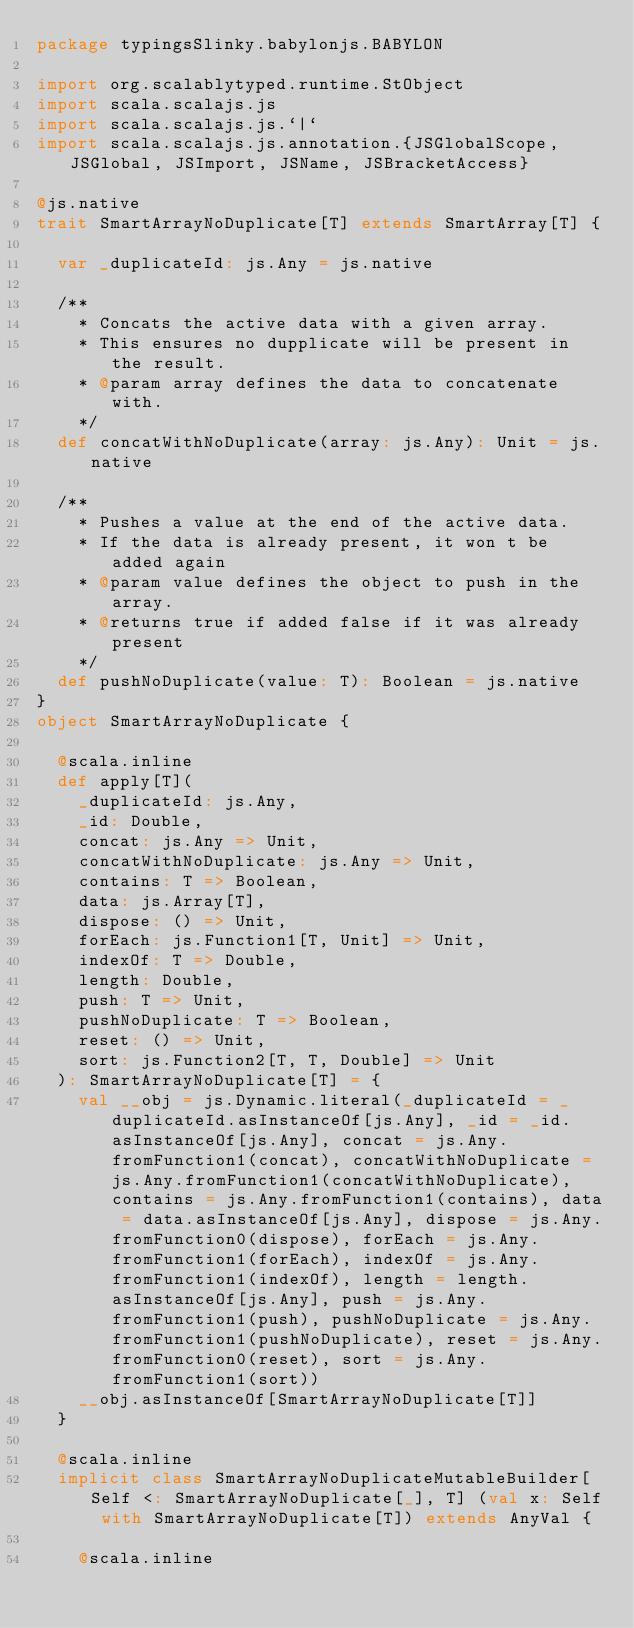Convert code to text. <code><loc_0><loc_0><loc_500><loc_500><_Scala_>package typingsSlinky.babylonjs.BABYLON

import org.scalablytyped.runtime.StObject
import scala.scalajs.js
import scala.scalajs.js.`|`
import scala.scalajs.js.annotation.{JSGlobalScope, JSGlobal, JSImport, JSName, JSBracketAccess}

@js.native
trait SmartArrayNoDuplicate[T] extends SmartArray[T] {
  
  var _duplicateId: js.Any = js.native
  
  /**
    * Concats the active data with a given array.
    * This ensures no dupplicate will be present in the result.
    * @param array defines the data to concatenate with.
    */
  def concatWithNoDuplicate(array: js.Any): Unit = js.native
  
  /**
    * Pushes a value at the end of the active data.
    * If the data is already present, it won t be added again
    * @param value defines the object to push in the array.
    * @returns true if added false if it was already present
    */
  def pushNoDuplicate(value: T): Boolean = js.native
}
object SmartArrayNoDuplicate {
  
  @scala.inline
  def apply[T](
    _duplicateId: js.Any,
    _id: Double,
    concat: js.Any => Unit,
    concatWithNoDuplicate: js.Any => Unit,
    contains: T => Boolean,
    data: js.Array[T],
    dispose: () => Unit,
    forEach: js.Function1[T, Unit] => Unit,
    indexOf: T => Double,
    length: Double,
    push: T => Unit,
    pushNoDuplicate: T => Boolean,
    reset: () => Unit,
    sort: js.Function2[T, T, Double] => Unit
  ): SmartArrayNoDuplicate[T] = {
    val __obj = js.Dynamic.literal(_duplicateId = _duplicateId.asInstanceOf[js.Any], _id = _id.asInstanceOf[js.Any], concat = js.Any.fromFunction1(concat), concatWithNoDuplicate = js.Any.fromFunction1(concatWithNoDuplicate), contains = js.Any.fromFunction1(contains), data = data.asInstanceOf[js.Any], dispose = js.Any.fromFunction0(dispose), forEach = js.Any.fromFunction1(forEach), indexOf = js.Any.fromFunction1(indexOf), length = length.asInstanceOf[js.Any], push = js.Any.fromFunction1(push), pushNoDuplicate = js.Any.fromFunction1(pushNoDuplicate), reset = js.Any.fromFunction0(reset), sort = js.Any.fromFunction1(sort))
    __obj.asInstanceOf[SmartArrayNoDuplicate[T]]
  }
  
  @scala.inline
  implicit class SmartArrayNoDuplicateMutableBuilder[Self <: SmartArrayNoDuplicate[_], T] (val x: Self with SmartArrayNoDuplicate[T]) extends AnyVal {
    
    @scala.inline</code> 